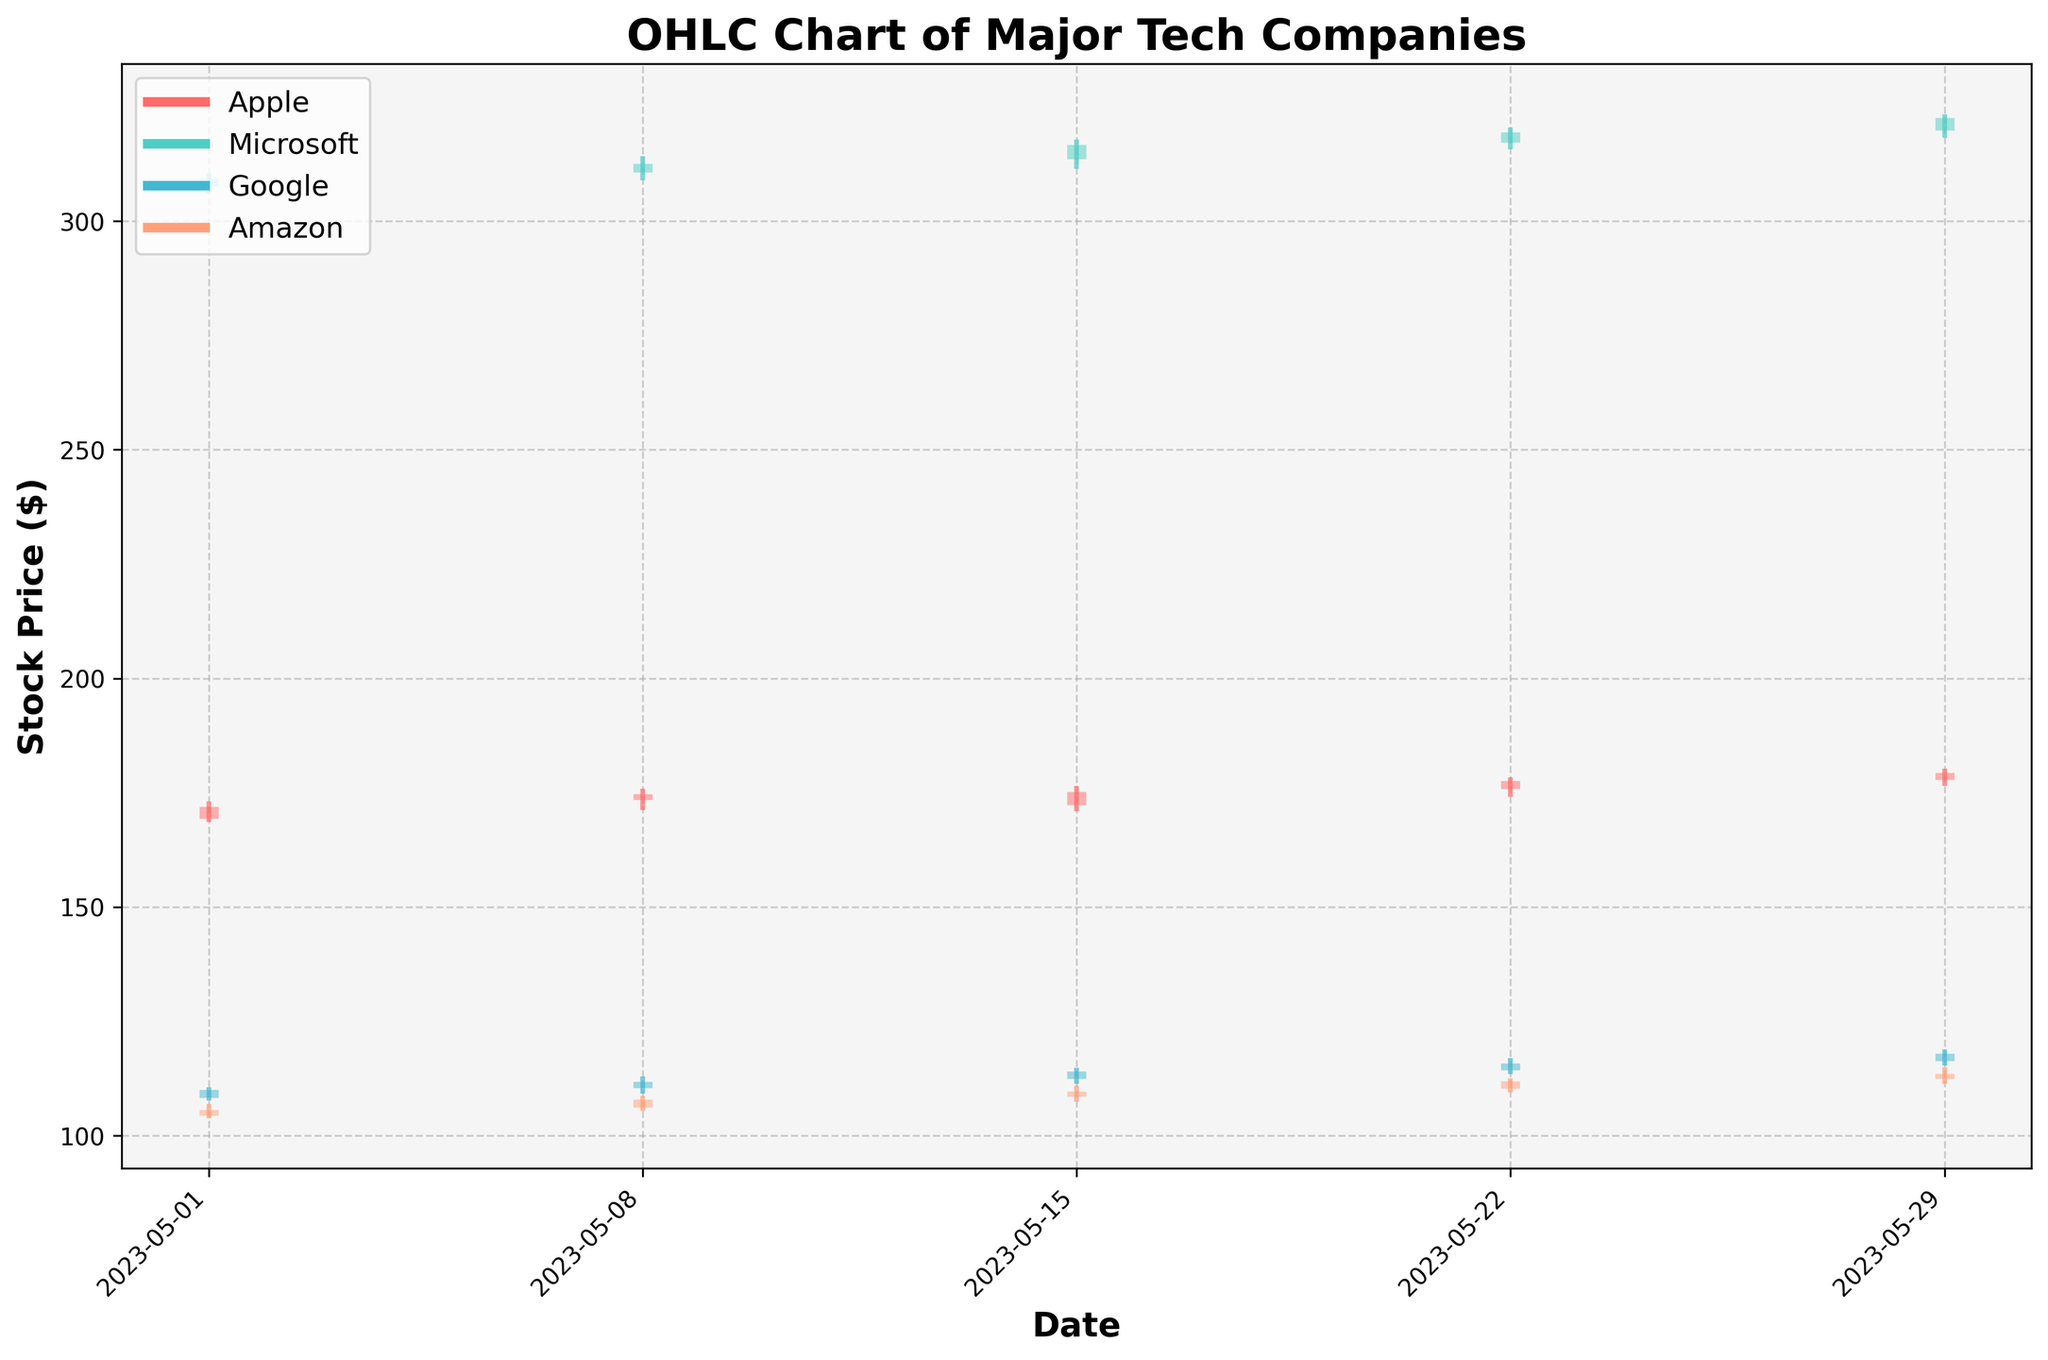What is the title of the chart? The title of the chart is typically located at the top of the figure and is designed to give an overview of what the chart represents. In this case, it clearly states "OHLC Chart of Major Tech Companies."
Answer: OHLC Chart of Major Tech Companies What do the X-axis and Y-axis represent in this chart? The X-axis represents the date of the stock price, while the Y-axis represents the stock price in dollars. These axes help in understanding how stock prices change over time.
Answer: The X-axis represents the date, and the Y-axis represents the stock price in dollars Which company's stock had the highest closing price on May 29, 2023? We need to look at the closing prices for all companies on May 29, 2023. Apple closed at $179.34, Microsoft at $322.67, Google at $117.98, and Amazon at $113.56. The highest closing price on that date was Microsoft's.
Answer: Microsoft What color represents Amazon's stock data in the chart? The colors are assigned to different companies for differentiation. According to the provided code, one of the colors represents Amazon. By elimination, Amazon's color appears to be the shade used for the fourth company.
Answer: A shade resembling light salmon How did Google's closing price change from May 1 to May 29? To determine the change in Google's closing price, compare the closing price on May 1, which was $109.98, with the closing price on May 29, which was $117.98.
Answer: Increased by $8.00 Which company showed the least volatility in stock prices throughout the month of May 2023? Volatility can be observed by looking at the difference between the high and low prices over time. Since the stocks’ highs and lows are visually represented, we compare the lengths of vertical lines for each company to determine Amazon had the least vertical length.
Answer: Amazon On which date did Apple’s stock price close higher than its opening price by the largest margin? We need to compare the difference between the closing and opening prices across all dates for Apple. Apple closed at $171.99 (on May 1), $174.65 (May 8), $175.23 (May 15), $177.56 (May 22), and $179.34 (May 29) while opening at $169.28, $173.50, $172.31, $175.89, and $177.89 respectively. May 15 had the largest margin.
Answer: May 15, 2023 Did any company's stock close lower than its opening price on May 1, 2023? To answer this question, we need to compare the opening and closing prices for each company on May 1, 2023. Apple, Microsoft, Google, and Amazon all show that their closing prices were higher than their opening prices on that date.
Answer: No Which company had the most consistent increase in its stock prices over the given dates? To determine consistency, we check if the closing price on each successive date is higher than the previous closing for each company. Observing the chart shows that all companies’ stock prices visually increased over the time periods consistently, but Apple displayed a noticeable and most significant, steady increase.
Answer: Apple What is the difference in the highest price of Apple's stock between May 8 and May 29, 2023? The highest price on May 8 was $175.89, and on May 29 it was $180.23. The difference can be calculated as $180.23 - $175.89.
Answer: $4.34 